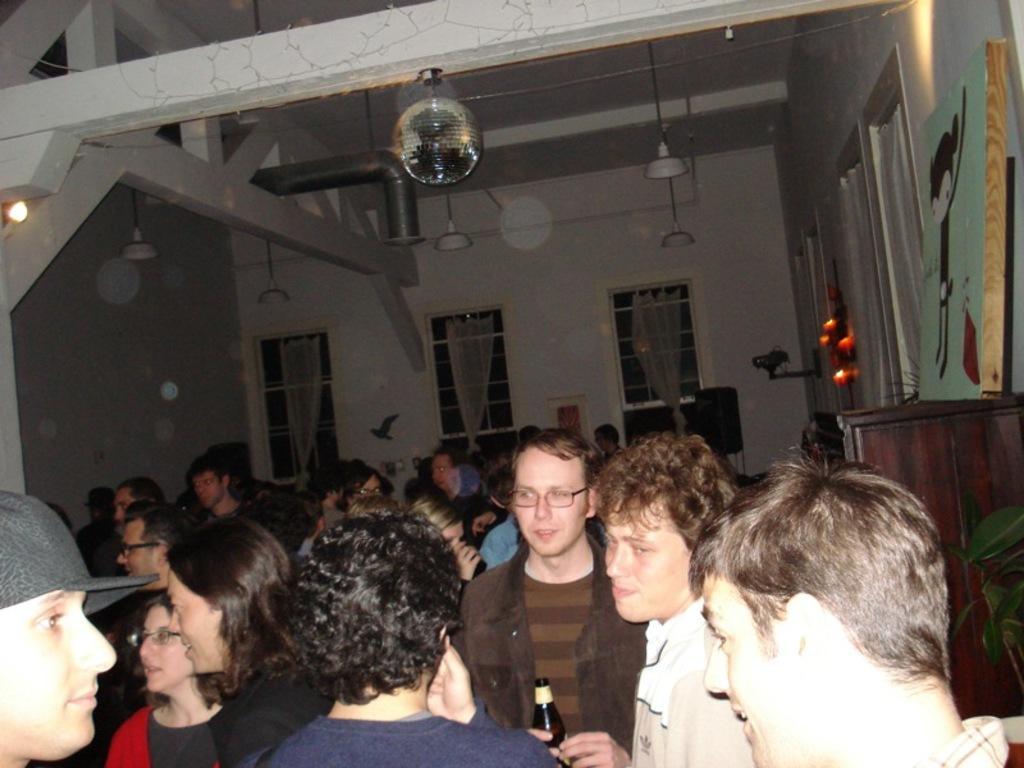Could you give a brief overview of what you see in this image? In this picture I can see some people are in side the building, windows to the walls and some lights and few things are placed around. 